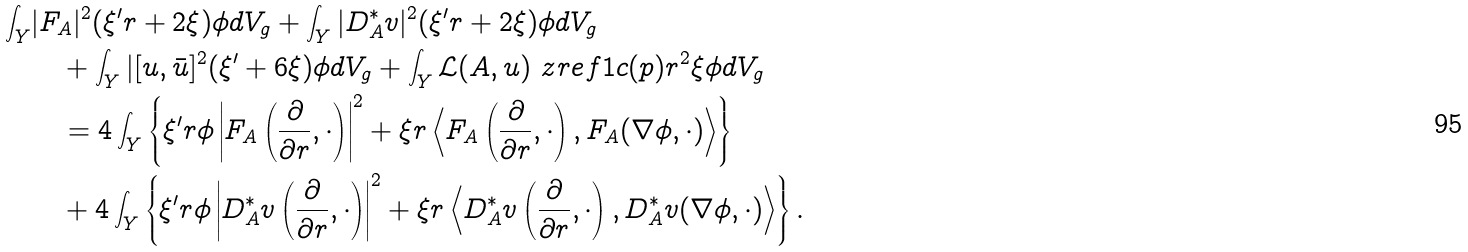Convert formula to latex. <formula><loc_0><loc_0><loc_500><loc_500>\int _ { Y } & | F _ { A } | ^ { 2 } ( \xi ^ { \prime } r + 2 \xi ) \phi d V _ { g } + \int _ { Y } | D _ { A } ^ { * } v | ^ { 2 } ( \xi ^ { \prime } r + 2 \xi ) \phi d V _ { g } \\ & \quad + \int _ { Y } | [ u , \bar { u } ] ^ { 2 } ( \xi ^ { \prime } + 6 \xi ) \phi d V _ { g } + \int _ { Y } \mathcal { L } ( A , u ) \ z r e f { 1 } c ( p ) r ^ { 2 } \xi \phi d V _ { g } \\ & \quad = 4 \int _ { Y } \left \{ \xi ^ { \prime } r \phi \left | F _ { A } \left ( \frac { \partial } { \partial r } , \cdot \right ) \right | ^ { 2 } + \xi r \left \langle F _ { A } \left ( \frac { \partial } { \partial r } , \cdot \right ) , F _ { A } ( \nabla \phi , \cdot ) \right \rangle \right \} \\ & \quad + 4 \int _ { Y } \left \{ \xi ^ { \prime } r \phi \left | D _ { A } ^ { * } v \left ( \frac { \partial } { \partial r } , \cdot \right ) \right | ^ { 2 } + \xi r \left \langle D _ { A } ^ { * } v \left ( \frac { \partial } { \partial r } , \cdot \right ) , D _ { A } ^ { * } v ( \nabla \phi , \cdot ) \right \rangle \right \} .</formula> 